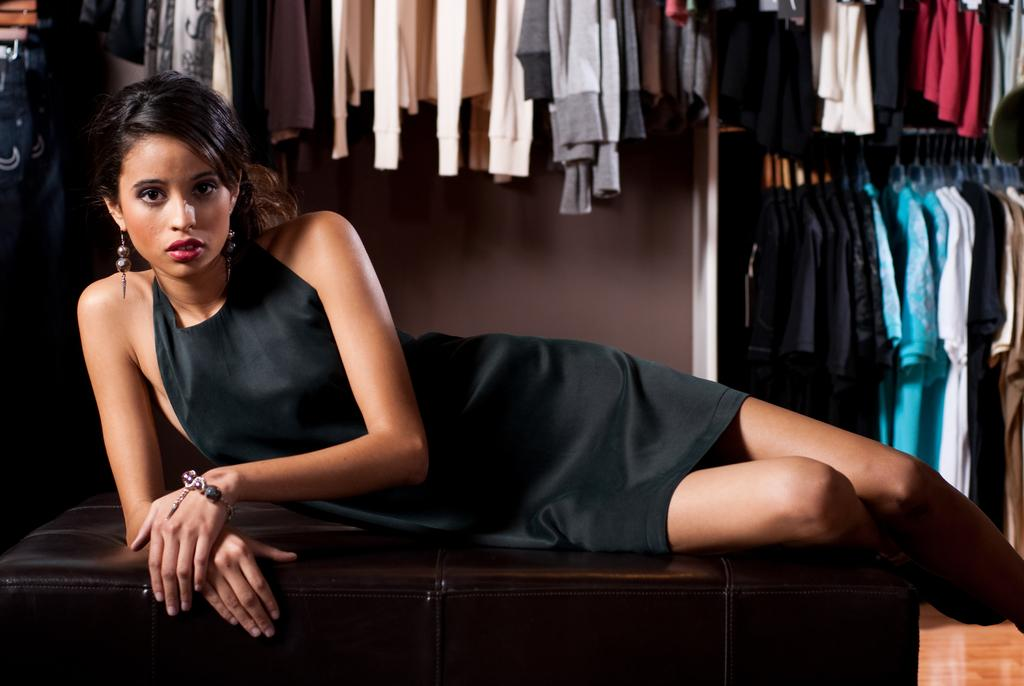What is the woman in the image doing? The woman is laying on a bench in the image. What can be seen in the background of the image? Clothes hanging on clothes hangers and a wall are visible in the background. How many pizzas are being delivered to the woman in the image? There are no pizzas present in the image, and no indication of any deliveries. 